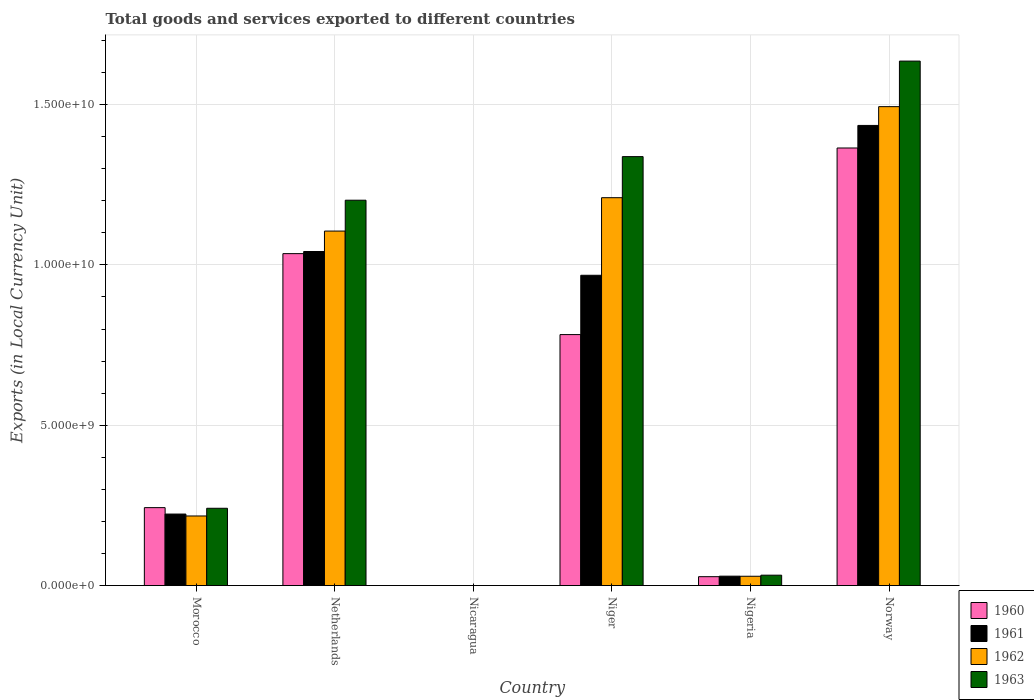How many different coloured bars are there?
Make the answer very short. 4. How many groups of bars are there?
Provide a succinct answer. 6. Are the number of bars per tick equal to the number of legend labels?
Ensure brevity in your answer.  Yes. Are the number of bars on each tick of the X-axis equal?
Your response must be concise. Yes. How many bars are there on the 5th tick from the left?
Provide a short and direct response. 4. In how many cases, is the number of bars for a given country not equal to the number of legend labels?
Provide a short and direct response. 0. What is the Amount of goods and services exports in 1961 in Netherlands?
Provide a succinct answer. 1.04e+1. Across all countries, what is the maximum Amount of goods and services exports in 1963?
Provide a succinct answer. 1.64e+1. Across all countries, what is the minimum Amount of goods and services exports in 1962?
Your answer should be very brief. 0.15. In which country was the Amount of goods and services exports in 1960 minimum?
Your response must be concise. Nicaragua. What is the total Amount of goods and services exports in 1960 in the graph?
Give a very brief answer. 3.45e+1. What is the difference between the Amount of goods and services exports in 1962 in Niger and that in Norway?
Ensure brevity in your answer.  -2.84e+09. What is the difference between the Amount of goods and services exports in 1963 in Norway and the Amount of goods and services exports in 1960 in Nicaragua?
Your answer should be compact. 1.64e+1. What is the average Amount of goods and services exports in 1961 per country?
Offer a terse response. 6.16e+09. What is the difference between the Amount of goods and services exports of/in 1961 and Amount of goods and services exports of/in 1960 in Morocco?
Your response must be concise. -2.00e+08. What is the ratio of the Amount of goods and services exports in 1960 in Nicaragua to that in Niger?
Offer a very short reply. 1.420758352495891e-11. Is the Amount of goods and services exports in 1960 in Morocco less than that in Netherlands?
Offer a terse response. Yes. What is the difference between the highest and the second highest Amount of goods and services exports in 1962?
Ensure brevity in your answer.  3.88e+09. What is the difference between the highest and the lowest Amount of goods and services exports in 1962?
Provide a succinct answer. 1.49e+1. In how many countries, is the Amount of goods and services exports in 1961 greater than the average Amount of goods and services exports in 1961 taken over all countries?
Your response must be concise. 3. Is the sum of the Amount of goods and services exports in 1961 in Niger and Nigeria greater than the maximum Amount of goods and services exports in 1963 across all countries?
Your answer should be very brief. No. What does the 1st bar from the left in Norway represents?
Provide a short and direct response. 1960. What does the 4th bar from the right in Nicaragua represents?
Provide a succinct answer. 1960. What is the difference between two consecutive major ticks on the Y-axis?
Give a very brief answer. 5.00e+09. How are the legend labels stacked?
Make the answer very short. Vertical. What is the title of the graph?
Offer a terse response. Total goods and services exported to different countries. What is the label or title of the X-axis?
Offer a terse response. Country. What is the label or title of the Y-axis?
Provide a succinct answer. Exports (in Local Currency Unit). What is the Exports (in Local Currency Unit) of 1960 in Morocco?
Make the answer very short. 2.43e+09. What is the Exports (in Local Currency Unit) of 1961 in Morocco?
Make the answer very short. 2.23e+09. What is the Exports (in Local Currency Unit) of 1962 in Morocco?
Provide a short and direct response. 2.17e+09. What is the Exports (in Local Currency Unit) in 1963 in Morocco?
Give a very brief answer. 2.41e+09. What is the Exports (in Local Currency Unit) in 1960 in Netherlands?
Give a very brief answer. 1.04e+1. What is the Exports (in Local Currency Unit) of 1961 in Netherlands?
Your response must be concise. 1.04e+1. What is the Exports (in Local Currency Unit) of 1962 in Netherlands?
Provide a short and direct response. 1.11e+1. What is the Exports (in Local Currency Unit) of 1963 in Netherlands?
Provide a short and direct response. 1.20e+1. What is the Exports (in Local Currency Unit) of 1960 in Nicaragua?
Make the answer very short. 0.11. What is the Exports (in Local Currency Unit) in 1961 in Nicaragua?
Provide a short and direct response. 0.12. What is the Exports (in Local Currency Unit) of 1962 in Nicaragua?
Your answer should be compact. 0.15. What is the Exports (in Local Currency Unit) of 1963 in Nicaragua?
Your answer should be very brief. 0.18. What is the Exports (in Local Currency Unit) in 1960 in Niger?
Your answer should be very brief. 7.83e+09. What is the Exports (in Local Currency Unit) in 1961 in Niger?
Keep it short and to the point. 9.68e+09. What is the Exports (in Local Currency Unit) of 1962 in Niger?
Offer a terse response. 1.21e+1. What is the Exports (in Local Currency Unit) of 1963 in Niger?
Offer a terse response. 1.34e+1. What is the Exports (in Local Currency Unit) in 1960 in Nigeria?
Ensure brevity in your answer.  2.77e+08. What is the Exports (in Local Currency Unit) in 1961 in Nigeria?
Offer a very short reply. 2.93e+08. What is the Exports (in Local Currency Unit) of 1962 in Nigeria?
Keep it short and to the point. 2.90e+08. What is the Exports (in Local Currency Unit) in 1963 in Nigeria?
Your answer should be very brief. 3.24e+08. What is the Exports (in Local Currency Unit) of 1960 in Norway?
Provide a succinct answer. 1.36e+1. What is the Exports (in Local Currency Unit) in 1961 in Norway?
Provide a short and direct response. 1.43e+1. What is the Exports (in Local Currency Unit) in 1962 in Norway?
Your response must be concise. 1.49e+1. What is the Exports (in Local Currency Unit) in 1963 in Norway?
Keep it short and to the point. 1.64e+1. Across all countries, what is the maximum Exports (in Local Currency Unit) in 1960?
Keep it short and to the point. 1.36e+1. Across all countries, what is the maximum Exports (in Local Currency Unit) in 1961?
Ensure brevity in your answer.  1.43e+1. Across all countries, what is the maximum Exports (in Local Currency Unit) in 1962?
Ensure brevity in your answer.  1.49e+1. Across all countries, what is the maximum Exports (in Local Currency Unit) of 1963?
Offer a very short reply. 1.64e+1. Across all countries, what is the minimum Exports (in Local Currency Unit) in 1960?
Provide a short and direct response. 0.11. Across all countries, what is the minimum Exports (in Local Currency Unit) in 1961?
Ensure brevity in your answer.  0.12. Across all countries, what is the minimum Exports (in Local Currency Unit) in 1962?
Your answer should be very brief. 0.15. Across all countries, what is the minimum Exports (in Local Currency Unit) in 1963?
Make the answer very short. 0.18. What is the total Exports (in Local Currency Unit) in 1960 in the graph?
Your answer should be compact. 3.45e+1. What is the total Exports (in Local Currency Unit) in 1961 in the graph?
Give a very brief answer. 3.70e+1. What is the total Exports (in Local Currency Unit) of 1962 in the graph?
Provide a succinct answer. 4.05e+1. What is the total Exports (in Local Currency Unit) of 1963 in the graph?
Give a very brief answer. 4.45e+1. What is the difference between the Exports (in Local Currency Unit) in 1960 in Morocco and that in Netherlands?
Your answer should be compact. -7.92e+09. What is the difference between the Exports (in Local Currency Unit) in 1961 in Morocco and that in Netherlands?
Offer a terse response. -8.19e+09. What is the difference between the Exports (in Local Currency Unit) in 1962 in Morocco and that in Netherlands?
Offer a very short reply. -8.88e+09. What is the difference between the Exports (in Local Currency Unit) in 1963 in Morocco and that in Netherlands?
Your response must be concise. -9.61e+09. What is the difference between the Exports (in Local Currency Unit) in 1960 in Morocco and that in Nicaragua?
Your answer should be very brief. 2.43e+09. What is the difference between the Exports (in Local Currency Unit) of 1961 in Morocco and that in Nicaragua?
Provide a short and direct response. 2.23e+09. What is the difference between the Exports (in Local Currency Unit) of 1962 in Morocco and that in Nicaragua?
Your response must be concise. 2.17e+09. What is the difference between the Exports (in Local Currency Unit) of 1963 in Morocco and that in Nicaragua?
Your answer should be very brief. 2.41e+09. What is the difference between the Exports (in Local Currency Unit) in 1960 in Morocco and that in Niger?
Your answer should be compact. -5.40e+09. What is the difference between the Exports (in Local Currency Unit) of 1961 in Morocco and that in Niger?
Give a very brief answer. -7.45e+09. What is the difference between the Exports (in Local Currency Unit) in 1962 in Morocco and that in Niger?
Your answer should be very brief. -9.92e+09. What is the difference between the Exports (in Local Currency Unit) of 1963 in Morocco and that in Niger?
Ensure brevity in your answer.  -1.10e+1. What is the difference between the Exports (in Local Currency Unit) in 1960 in Morocco and that in Nigeria?
Your answer should be very brief. 2.15e+09. What is the difference between the Exports (in Local Currency Unit) in 1961 in Morocco and that in Nigeria?
Your answer should be very brief. 1.94e+09. What is the difference between the Exports (in Local Currency Unit) in 1962 in Morocco and that in Nigeria?
Offer a very short reply. 1.88e+09. What is the difference between the Exports (in Local Currency Unit) in 1963 in Morocco and that in Nigeria?
Provide a succinct answer. 2.09e+09. What is the difference between the Exports (in Local Currency Unit) in 1960 in Morocco and that in Norway?
Your response must be concise. -1.12e+1. What is the difference between the Exports (in Local Currency Unit) in 1961 in Morocco and that in Norway?
Offer a terse response. -1.21e+1. What is the difference between the Exports (in Local Currency Unit) of 1962 in Morocco and that in Norway?
Your answer should be compact. -1.28e+1. What is the difference between the Exports (in Local Currency Unit) in 1963 in Morocco and that in Norway?
Ensure brevity in your answer.  -1.39e+1. What is the difference between the Exports (in Local Currency Unit) in 1960 in Netherlands and that in Nicaragua?
Your answer should be very brief. 1.04e+1. What is the difference between the Exports (in Local Currency Unit) of 1961 in Netherlands and that in Nicaragua?
Offer a very short reply. 1.04e+1. What is the difference between the Exports (in Local Currency Unit) in 1962 in Netherlands and that in Nicaragua?
Offer a very short reply. 1.11e+1. What is the difference between the Exports (in Local Currency Unit) of 1963 in Netherlands and that in Nicaragua?
Ensure brevity in your answer.  1.20e+1. What is the difference between the Exports (in Local Currency Unit) of 1960 in Netherlands and that in Niger?
Your answer should be very brief. 2.52e+09. What is the difference between the Exports (in Local Currency Unit) of 1961 in Netherlands and that in Niger?
Your answer should be very brief. 7.41e+08. What is the difference between the Exports (in Local Currency Unit) in 1962 in Netherlands and that in Niger?
Ensure brevity in your answer.  -1.04e+09. What is the difference between the Exports (in Local Currency Unit) of 1963 in Netherlands and that in Niger?
Offer a terse response. -1.36e+09. What is the difference between the Exports (in Local Currency Unit) of 1960 in Netherlands and that in Nigeria?
Offer a terse response. 1.01e+1. What is the difference between the Exports (in Local Currency Unit) of 1961 in Netherlands and that in Nigeria?
Your answer should be compact. 1.01e+1. What is the difference between the Exports (in Local Currency Unit) of 1962 in Netherlands and that in Nigeria?
Provide a short and direct response. 1.08e+1. What is the difference between the Exports (in Local Currency Unit) of 1963 in Netherlands and that in Nigeria?
Provide a succinct answer. 1.17e+1. What is the difference between the Exports (in Local Currency Unit) of 1960 in Netherlands and that in Norway?
Offer a very short reply. -3.29e+09. What is the difference between the Exports (in Local Currency Unit) in 1961 in Netherlands and that in Norway?
Ensure brevity in your answer.  -3.93e+09. What is the difference between the Exports (in Local Currency Unit) in 1962 in Netherlands and that in Norway?
Your answer should be compact. -3.88e+09. What is the difference between the Exports (in Local Currency Unit) in 1963 in Netherlands and that in Norway?
Make the answer very short. -4.34e+09. What is the difference between the Exports (in Local Currency Unit) in 1960 in Nicaragua and that in Niger?
Keep it short and to the point. -7.83e+09. What is the difference between the Exports (in Local Currency Unit) in 1961 in Nicaragua and that in Niger?
Give a very brief answer. -9.68e+09. What is the difference between the Exports (in Local Currency Unit) of 1962 in Nicaragua and that in Niger?
Offer a terse response. -1.21e+1. What is the difference between the Exports (in Local Currency Unit) of 1963 in Nicaragua and that in Niger?
Your answer should be compact. -1.34e+1. What is the difference between the Exports (in Local Currency Unit) of 1960 in Nicaragua and that in Nigeria?
Give a very brief answer. -2.77e+08. What is the difference between the Exports (in Local Currency Unit) in 1961 in Nicaragua and that in Nigeria?
Ensure brevity in your answer.  -2.93e+08. What is the difference between the Exports (in Local Currency Unit) of 1962 in Nicaragua and that in Nigeria?
Your answer should be compact. -2.90e+08. What is the difference between the Exports (in Local Currency Unit) of 1963 in Nicaragua and that in Nigeria?
Give a very brief answer. -3.24e+08. What is the difference between the Exports (in Local Currency Unit) in 1960 in Nicaragua and that in Norway?
Your answer should be very brief. -1.36e+1. What is the difference between the Exports (in Local Currency Unit) of 1961 in Nicaragua and that in Norway?
Your answer should be compact. -1.43e+1. What is the difference between the Exports (in Local Currency Unit) of 1962 in Nicaragua and that in Norway?
Provide a short and direct response. -1.49e+1. What is the difference between the Exports (in Local Currency Unit) of 1963 in Nicaragua and that in Norway?
Provide a short and direct response. -1.64e+1. What is the difference between the Exports (in Local Currency Unit) in 1960 in Niger and that in Nigeria?
Your answer should be very brief. 7.55e+09. What is the difference between the Exports (in Local Currency Unit) of 1961 in Niger and that in Nigeria?
Offer a very short reply. 9.38e+09. What is the difference between the Exports (in Local Currency Unit) in 1962 in Niger and that in Nigeria?
Offer a very short reply. 1.18e+1. What is the difference between the Exports (in Local Currency Unit) in 1963 in Niger and that in Nigeria?
Provide a succinct answer. 1.31e+1. What is the difference between the Exports (in Local Currency Unit) in 1960 in Niger and that in Norway?
Make the answer very short. -5.82e+09. What is the difference between the Exports (in Local Currency Unit) in 1961 in Niger and that in Norway?
Your answer should be compact. -4.67e+09. What is the difference between the Exports (in Local Currency Unit) in 1962 in Niger and that in Norway?
Your answer should be compact. -2.84e+09. What is the difference between the Exports (in Local Currency Unit) of 1963 in Niger and that in Norway?
Provide a short and direct response. -2.98e+09. What is the difference between the Exports (in Local Currency Unit) of 1960 in Nigeria and that in Norway?
Give a very brief answer. -1.34e+1. What is the difference between the Exports (in Local Currency Unit) of 1961 in Nigeria and that in Norway?
Provide a short and direct response. -1.41e+1. What is the difference between the Exports (in Local Currency Unit) in 1962 in Nigeria and that in Norway?
Give a very brief answer. -1.46e+1. What is the difference between the Exports (in Local Currency Unit) in 1963 in Nigeria and that in Norway?
Make the answer very short. -1.60e+1. What is the difference between the Exports (in Local Currency Unit) of 1960 in Morocco and the Exports (in Local Currency Unit) of 1961 in Netherlands?
Provide a succinct answer. -7.99e+09. What is the difference between the Exports (in Local Currency Unit) in 1960 in Morocco and the Exports (in Local Currency Unit) in 1962 in Netherlands?
Provide a succinct answer. -8.62e+09. What is the difference between the Exports (in Local Currency Unit) of 1960 in Morocco and the Exports (in Local Currency Unit) of 1963 in Netherlands?
Keep it short and to the point. -9.59e+09. What is the difference between the Exports (in Local Currency Unit) in 1961 in Morocco and the Exports (in Local Currency Unit) in 1962 in Netherlands?
Your response must be concise. -8.82e+09. What is the difference between the Exports (in Local Currency Unit) in 1961 in Morocco and the Exports (in Local Currency Unit) in 1963 in Netherlands?
Provide a succinct answer. -9.79e+09. What is the difference between the Exports (in Local Currency Unit) of 1962 in Morocco and the Exports (in Local Currency Unit) of 1963 in Netherlands?
Provide a succinct answer. -9.85e+09. What is the difference between the Exports (in Local Currency Unit) in 1960 in Morocco and the Exports (in Local Currency Unit) in 1961 in Nicaragua?
Provide a short and direct response. 2.43e+09. What is the difference between the Exports (in Local Currency Unit) of 1960 in Morocco and the Exports (in Local Currency Unit) of 1962 in Nicaragua?
Your response must be concise. 2.43e+09. What is the difference between the Exports (in Local Currency Unit) of 1960 in Morocco and the Exports (in Local Currency Unit) of 1963 in Nicaragua?
Ensure brevity in your answer.  2.43e+09. What is the difference between the Exports (in Local Currency Unit) in 1961 in Morocco and the Exports (in Local Currency Unit) in 1962 in Nicaragua?
Your response must be concise. 2.23e+09. What is the difference between the Exports (in Local Currency Unit) in 1961 in Morocco and the Exports (in Local Currency Unit) in 1963 in Nicaragua?
Ensure brevity in your answer.  2.23e+09. What is the difference between the Exports (in Local Currency Unit) in 1962 in Morocco and the Exports (in Local Currency Unit) in 1963 in Nicaragua?
Offer a terse response. 2.17e+09. What is the difference between the Exports (in Local Currency Unit) in 1960 in Morocco and the Exports (in Local Currency Unit) in 1961 in Niger?
Make the answer very short. -7.25e+09. What is the difference between the Exports (in Local Currency Unit) in 1960 in Morocco and the Exports (in Local Currency Unit) in 1962 in Niger?
Keep it short and to the point. -9.66e+09. What is the difference between the Exports (in Local Currency Unit) of 1960 in Morocco and the Exports (in Local Currency Unit) of 1963 in Niger?
Your answer should be very brief. -1.09e+1. What is the difference between the Exports (in Local Currency Unit) in 1961 in Morocco and the Exports (in Local Currency Unit) in 1962 in Niger?
Offer a very short reply. -9.86e+09. What is the difference between the Exports (in Local Currency Unit) in 1961 in Morocco and the Exports (in Local Currency Unit) in 1963 in Niger?
Provide a succinct answer. -1.11e+1. What is the difference between the Exports (in Local Currency Unit) of 1962 in Morocco and the Exports (in Local Currency Unit) of 1963 in Niger?
Your answer should be compact. -1.12e+1. What is the difference between the Exports (in Local Currency Unit) of 1960 in Morocco and the Exports (in Local Currency Unit) of 1961 in Nigeria?
Give a very brief answer. 2.14e+09. What is the difference between the Exports (in Local Currency Unit) in 1960 in Morocco and the Exports (in Local Currency Unit) in 1962 in Nigeria?
Offer a terse response. 2.14e+09. What is the difference between the Exports (in Local Currency Unit) in 1960 in Morocco and the Exports (in Local Currency Unit) in 1963 in Nigeria?
Offer a terse response. 2.11e+09. What is the difference between the Exports (in Local Currency Unit) of 1961 in Morocco and the Exports (in Local Currency Unit) of 1962 in Nigeria?
Give a very brief answer. 1.94e+09. What is the difference between the Exports (in Local Currency Unit) in 1961 in Morocco and the Exports (in Local Currency Unit) in 1963 in Nigeria?
Provide a succinct answer. 1.91e+09. What is the difference between the Exports (in Local Currency Unit) of 1962 in Morocco and the Exports (in Local Currency Unit) of 1963 in Nigeria?
Give a very brief answer. 1.85e+09. What is the difference between the Exports (in Local Currency Unit) in 1960 in Morocco and the Exports (in Local Currency Unit) in 1961 in Norway?
Offer a very short reply. -1.19e+1. What is the difference between the Exports (in Local Currency Unit) in 1960 in Morocco and the Exports (in Local Currency Unit) in 1962 in Norway?
Offer a very short reply. -1.25e+1. What is the difference between the Exports (in Local Currency Unit) of 1960 in Morocco and the Exports (in Local Currency Unit) of 1963 in Norway?
Your answer should be compact. -1.39e+1. What is the difference between the Exports (in Local Currency Unit) in 1961 in Morocco and the Exports (in Local Currency Unit) in 1962 in Norway?
Your answer should be compact. -1.27e+1. What is the difference between the Exports (in Local Currency Unit) in 1961 in Morocco and the Exports (in Local Currency Unit) in 1963 in Norway?
Your response must be concise. -1.41e+1. What is the difference between the Exports (in Local Currency Unit) in 1962 in Morocco and the Exports (in Local Currency Unit) in 1963 in Norway?
Give a very brief answer. -1.42e+1. What is the difference between the Exports (in Local Currency Unit) of 1960 in Netherlands and the Exports (in Local Currency Unit) of 1961 in Nicaragua?
Give a very brief answer. 1.04e+1. What is the difference between the Exports (in Local Currency Unit) of 1960 in Netherlands and the Exports (in Local Currency Unit) of 1962 in Nicaragua?
Provide a short and direct response. 1.04e+1. What is the difference between the Exports (in Local Currency Unit) of 1960 in Netherlands and the Exports (in Local Currency Unit) of 1963 in Nicaragua?
Make the answer very short. 1.04e+1. What is the difference between the Exports (in Local Currency Unit) in 1961 in Netherlands and the Exports (in Local Currency Unit) in 1962 in Nicaragua?
Give a very brief answer. 1.04e+1. What is the difference between the Exports (in Local Currency Unit) in 1961 in Netherlands and the Exports (in Local Currency Unit) in 1963 in Nicaragua?
Your answer should be compact. 1.04e+1. What is the difference between the Exports (in Local Currency Unit) in 1962 in Netherlands and the Exports (in Local Currency Unit) in 1963 in Nicaragua?
Give a very brief answer. 1.11e+1. What is the difference between the Exports (in Local Currency Unit) in 1960 in Netherlands and the Exports (in Local Currency Unit) in 1961 in Niger?
Offer a very short reply. 6.75e+08. What is the difference between the Exports (in Local Currency Unit) in 1960 in Netherlands and the Exports (in Local Currency Unit) in 1962 in Niger?
Keep it short and to the point. -1.74e+09. What is the difference between the Exports (in Local Currency Unit) of 1960 in Netherlands and the Exports (in Local Currency Unit) of 1963 in Niger?
Provide a short and direct response. -3.02e+09. What is the difference between the Exports (in Local Currency Unit) in 1961 in Netherlands and the Exports (in Local Currency Unit) in 1962 in Niger?
Give a very brief answer. -1.68e+09. What is the difference between the Exports (in Local Currency Unit) in 1961 in Netherlands and the Exports (in Local Currency Unit) in 1963 in Niger?
Offer a terse response. -2.96e+09. What is the difference between the Exports (in Local Currency Unit) in 1962 in Netherlands and the Exports (in Local Currency Unit) in 1963 in Niger?
Ensure brevity in your answer.  -2.32e+09. What is the difference between the Exports (in Local Currency Unit) of 1960 in Netherlands and the Exports (in Local Currency Unit) of 1961 in Nigeria?
Offer a terse response. 1.01e+1. What is the difference between the Exports (in Local Currency Unit) in 1960 in Netherlands and the Exports (in Local Currency Unit) in 1962 in Nigeria?
Keep it short and to the point. 1.01e+1. What is the difference between the Exports (in Local Currency Unit) in 1960 in Netherlands and the Exports (in Local Currency Unit) in 1963 in Nigeria?
Offer a very short reply. 1.00e+1. What is the difference between the Exports (in Local Currency Unit) in 1961 in Netherlands and the Exports (in Local Currency Unit) in 1962 in Nigeria?
Offer a very short reply. 1.01e+1. What is the difference between the Exports (in Local Currency Unit) of 1961 in Netherlands and the Exports (in Local Currency Unit) of 1963 in Nigeria?
Provide a succinct answer. 1.01e+1. What is the difference between the Exports (in Local Currency Unit) in 1962 in Netherlands and the Exports (in Local Currency Unit) in 1963 in Nigeria?
Provide a succinct answer. 1.07e+1. What is the difference between the Exports (in Local Currency Unit) in 1960 in Netherlands and the Exports (in Local Currency Unit) in 1961 in Norway?
Keep it short and to the point. -4.00e+09. What is the difference between the Exports (in Local Currency Unit) of 1960 in Netherlands and the Exports (in Local Currency Unit) of 1962 in Norway?
Your response must be concise. -4.58e+09. What is the difference between the Exports (in Local Currency Unit) in 1960 in Netherlands and the Exports (in Local Currency Unit) in 1963 in Norway?
Offer a very short reply. -6.00e+09. What is the difference between the Exports (in Local Currency Unit) of 1961 in Netherlands and the Exports (in Local Currency Unit) of 1962 in Norway?
Your answer should be very brief. -4.52e+09. What is the difference between the Exports (in Local Currency Unit) in 1961 in Netherlands and the Exports (in Local Currency Unit) in 1963 in Norway?
Give a very brief answer. -5.94e+09. What is the difference between the Exports (in Local Currency Unit) in 1962 in Netherlands and the Exports (in Local Currency Unit) in 1963 in Norway?
Keep it short and to the point. -5.30e+09. What is the difference between the Exports (in Local Currency Unit) of 1960 in Nicaragua and the Exports (in Local Currency Unit) of 1961 in Niger?
Keep it short and to the point. -9.68e+09. What is the difference between the Exports (in Local Currency Unit) of 1960 in Nicaragua and the Exports (in Local Currency Unit) of 1962 in Niger?
Ensure brevity in your answer.  -1.21e+1. What is the difference between the Exports (in Local Currency Unit) of 1960 in Nicaragua and the Exports (in Local Currency Unit) of 1963 in Niger?
Your answer should be very brief. -1.34e+1. What is the difference between the Exports (in Local Currency Unit) of 1961 in Nicaragua and the Exports (in Local Currency Unit) of 1962 in Niger?
Your response must be concise. -1.21e+1. What is the difference between the Exports (in Local Currency Unit) of 1961 in Nicaragua and the Exports (in Local Currency Unit) of 1963 in Niger?
Your response must be concise. -1.34e+1. What is the difference between the Exports (in Local Currency Unit) of 1962 in Nicaragua and the Exports (in Local Currency Unit) of 1963 in Niger?
Keep it short and to the point. -1.34e+1. What is the difference between the Exports (in Local Currency Unit) in 1960 in Nicaragua and the Exports (in Local Currency Unit) in 1961 in Nigeria?
Your answer should be compact. -2.93e+08. What is the difference between the Exports (in Local Currency Unit) in 1960 in Nicaragua and the Exports (in Local Currency Unit) in 1962 in Nigeria?
Your answer should be very brief. -2.90e+08. What is the difference between the Exports (in Local Currency Unit) in 1960 in Nicaragua and the Exports (in Local Currency Unit) in 1963 in Nigeria?
Offer a terse response. -3.24e+08. What is the difference between the Exports (in Local Currency Unit) in 1961 in Nicaragua and the Exports (in Local Currency Unit) in 1962 in Nigeria?
Give a very brief answer. -2.90e+08. What is the difference between the Exports (in Local Currency Unit) in 1961 in Nicaragua and the Exports (in Local Currency Unit) in 1963 in Nigeria?
Your answer should be very brief. -3.24e+08. What is the difference between the Exports (in Local Currency Unit) of 1962 in Nicaragua and the Exports (in Local Currency Unit) of 1963 in Nigeria?
Keep it short and to the point. -3.24e+08. What is the difference between the Exports (in Local Currency Unit) of 1960 in Nicaragua and the Exports (in Local Currency Unit) of 1961 in Norway?
Make the answer very short. -1.43e+1. What is the difference between the Exports (in Local Currency Unit) in 1960 in Nicaragua and the Exports (in Local Currency Unit) in 1962 in Norway?
Provide a short and direct response. -1.49e+1. What is the difference between the Exports (in Local Currency Unit) in 1960 in Nicaragua and the Exports (in Local Currency Unit) in 1963 in Norway?
Keep it short and to the point. -1.64e+1. What is the difference between the Exports (in Local Currency Unit) of 1961 in Nicaragua and the Exports (in Local Currency Unit) of 1962 in Norway?
Offer a terse response. -1.49e+1. What is the difference between the Exports (in Local Currency Unit) of 1961 in Nicaragua and the Exports (in Local Currency Unit) of 1963 in Norway?
Provide a short and direct response. -1.64e+1. What is the difference between the Exports (in Local Currency Unit) in 1962 in Nicaragua and the Exports (in Local Currency Unit) in 1963 in Norway?
Provide a succinct answer. -1.64e+1. What is the difference between the Exports (in Local Currency Unit) of 1960 in Niger and the Exports (in Local Currency Unit) of 1961 in Nigeria?
Your response must be concise. 7.53e+09. What is the difference between the Exports (in Local Currency Unit) in 1960 in Niger and the Exports (in Local Currency Unit) in 1962 in Nigeria?
Keep it short and to the point. 7.54e+09. What is the difference between the Exports (in Local Currency Unit) in 1960 in Niger and the Exports (in Local Currency Unit) in 1963 in Nigeria?
Offer a very short reply. 7.50e+09. What is the difference between the Exports (in Local Currency Unit) of 1961 in Niger and the Exports (in Local Currency Unit) of 1962 in Nigeria?
Offer a very short reply. 9.39e+09. What is the difference between the Exports (in Local Currency Unit) of 1961 in Niger and the Exports (in Local Currency Unit) of 1963 in Nigeria?
Offer a very short reply. 9.35e+09. What is the difference between the Exports (in Local Currency Unit) of 1962 in Niger and the Exports (in Local Currency Unit) of 1963 in Nigeria?
Make the answer very short. 1.18e+1. What is the difference between the Exports (in Local Currency Unit) of 1960 in Niger and the Exports (in Local Currency Unit) of 1961 in Norway?
Offer a terse response. -6.52e+09. What is the difference between the Exports (in Local Currency Unit) in 1960 in Niger and the Exports (in Local Currency Unit) in 1962 in Norway?
Your response must be concise. -7.11e+09. What is the difference between the Exports (in Local Currency Unit) in 1960 in Niger and the Exports (in Local Currency Unit) in 1963 in Norway?
Your answer should be compact. -8.53e+09. What is the difference between the Exports (in Local Currency Unit) in 1961 in Niger and the Exports (in Local Currency Unit) in 1962 in Norway?
Your response must be concise. -5.26e+09. What is the difference between the Exports (in Local Currency Unit) in 1961 in Niger and the Exports (in Local Currency Unit) in 1963 in Norway?
Your response must be concise. -6.68e+09. What is the difference between the Exports (in Local Currency Unit) of 1962 in Niger and the Exports (in Local Currency Unit) of 1963 in Norway?
Ensure brevity in your answer.  -4.26e+09. What is the difference between the Exports (in Local Currency Unit) of 1960 in Nigeria and the Exports (in Local Currency Unit) of 1961 in Norway?
Provide a succinct answer. -1.41e+1. What is the difference between the Exports (in Local Currency Unit) of 1960 in Nigeria and the Exports (in Local Currency Unit) of 1962 in Norway?
Keep it short and to the point. -1.47e+1. What is the difference between the Exports (in Local Currency Unit) in 1960 in Nigeria and the Exports (in Local Currency Unit) in 1963 in Norway?
Ensure brevity in your answer.  -1.61e+1. What is the difference between the Exports (in Local Currency Unit) in 1961 in Nigeria and the Exports (in Local Currency Unit) in 1962 in Norway?
Provide a succinct answer. -1.46e+1. What is the difference between the Exports (in Local Currency Unit) in 1961 in Nigeria and the Exports (in Local Currency Unit) in 1963 in Norway?
Ensure brevity in your answer.  -1.61e+1. What is the difference between the Exports (in Local Currency Unit) of 1962 in Nigeria and the Exports (in Local Currency Unit) of 1963 in Norway?
Offer a very short reply. -1.61e+1. What is the average Exports (in Local Currency Unit) of 1960 per country?
Give a very brief answer. 5.75e+09. What is the average Exports (in Local Currency Unit) in 1961 per country?
Provide a succinct answer. 6.16e+09. What is the average Exports (in Local Currency Unit) in 1962 per country?
Your response must be concise. 6.76e+09. What is the average Exports (in Local Currency Unit) in 1963 per country?
Provide a succinct answer. 7.41e+09. What is the difference between the Exports (in Local Currency Unit) in 1960 and Exports (in Local Currency Unit) in 1961 in Morocco?
Your response must be concise. 2.00e+08. What is the difference between the Exports (in Local Currency Unit) of 1960 and Exports (in Local Currency Unit) of 1962 in Morocco?
Make the answer very short. 2.60e+08. What is the difference between the Exports (in Local Currency Unit) in 1961 and Exports (in Local Currency Unit) in 1962 in Morocco?
Give a very brief answer. 6.00e+07. What is the difference between the Exports (in Local Currency Unit) in 1961 and Exports (in Local Currency Unit) in 1963 in Morocco?
Provide a short and direct response. -1.80e+08. What is the difference between the Exports (in Local Currency Unit) in 1962 and Exports (in Local Currency Unit) in 1963 in Morocco?
Offer a terse response. -2.40e+08. What is the difference between the Exports (in Local Currency Unit) in 1960 and Exports (in Local Currency Unit) in 1961 in Netherlands?
Give a very brief answer. -6.60e+07. What is the difference between the Exports (in Local Currency Unit) in 1960 and Exports (in Local Currency Unit) in 1962 in Netherlands?
Keep it short and to the point. -7.03e+08. What is the difference between the Exports (in Local Currency Unit) of 1960 and Exports (in Local Currency Unit) of 1963 in Netherlands?
Ensure brevity in your answer.  -1.67e+09. What is the difference between the Exports (in Local Currency Unit) of 1961 and Exports (in Local Currency Unit) of 1962 in Netherlands?
Your answer should be compact. -6.37e+08. What is the difference between the Exports (in Local Currency Unit) of 1961 and Exports (in Local Currency Unit) of 1963 in Netherlands?
Your answer should be very brief. -1.60e+09. What is the difference between the Exports (in Local Currency Unit) in 1962 and Exports (in Local Currency Unit) in 1963 in Netherlands?
Offer a terse response. -9.62e+08. What is the difference between the Exports (in Local Currency Unit) in 1960 and Exports (in Local Currency Unit) in 1961 in Nicaragua?
Make the answer very short. -0.01. What is the difference between the Exports (in Local Currency Unit) in 1960 and Exports (in Local Currency Unit) in 1962 in Nicaragua?
Offer a very short reply. -0.04. What is the difference between the Exports (in Local Currency Unit) of 1960 and Exports (in Local Currency Unit) of 1963 in Nicaragua?
Your response must be concise. -0.07. What is the difference between the Exports (in Local Currency Unit) of 1961 and Exports (in Local Currency Unit) of 1962 in Nicaragua?
Your response must be concise. -0.03. What is the difference between the Exports (in Local Currency Unit) in 1961 and Exports (in Local Currency Unit) in 1963 in Nicaragua?
Give a very brief answer. -0.06. What is the difference between the Exports (in Local Currency Unit) in 1962 and Exports (in Local Currency Unit) in 1963 in Nicaragua?
Your answer should be very brief. -0.03. What is the difference between the Exports (in Local Currency Unit) in 1960 and Exports (in Local Currency Unit) in 1961 in Niger?
Provide a short and direct response. -1.85e+09. What is the difference between the Exports (in Local Currency Unit) of 1960 and Exports (in Local Currency Unit) of 1962 in Niger?
Provide a succinct answer. -4.27e+09. What is the difference between the Exports (in Local Currency Unit) in 1960 and Exports (in Local Currency Unit) in 1963 in Niger?
Provide a succinct answer. -5.55e+09. What is the difference between the Exports (in Local Currency Unit) of 1961 and Exports (in Local Currency Unit) of 1962 in Niger?
Offer a terse response. -2.42e+09. What is the difference between the Exports (in Local Currency Unit) of 1961 and Exports (in Local Currency Unit) of 1963 in Niger?
Give a very brief answer. -3.70e+09. What is the difference between the Exports (in Local Currency Unit) in 1962 and Exports (in Local Currency Unit) in 1963 in Niger?
Your response must be concise. -1.28e+09. What is the difference between the Exports (in Local Currency Unit) in 1960 and Exports (in Local Currency Unit) in 1961 in Nigeria?
Provide a succinct answer. -1.61e+07. What is the difference between the Exports (in Local Currency Unit) of 1960 and Exports (in Local Currency Unit) of 1962 in Nigeria?
Ensure brevity in your answer.  -1.30e+07. What is the difference between the Exports (in Local Currency Unit) of 1960 and Exports (in Local Currency Unit) of 1963 in Nigeria?
Your answer should be compact. -4.69e+07. What is the difference between the Exports (in Local Currency Unit) of 1961 and Exports (in Local Currency Unit) of 1962 in Nigeria?
Your answer should be compact. 3.12e+06. What is the difference between the Exports (in Local Currency Unit) in 1961 and Exports (in Local Currency Unit) in 1963 in Nigeria?
Your response must be concise. -3.08e+07. What is the difference between the Exports (in Local Currency Unit) in 1962 and Exports (in Local Currency Unit) in 1963 in Nigeria?
Ensure brevity in your answer.  -3.40e+07. What is the difference between the Exports (in Local Currency Unit) of 1960 and Exports (in Local Currency Unit) of 1961 in Norway?
Give a very brief answer. -7.04e+08. What is the difference between the Exports (in Local Currency Unit) of 1960 and Exports (in Local Currency Unit) of 1962 in Norway?
Give a very brief answer. -1.29e+09. What is the difference between the Exports (in Local Currency Unit) of 1960 and Exports (in Local Currency Unit) of 1963 in Norway?
Ensure brevity in your answer.  -2.71e+09. What is the difference between the Exports (in Local Currency Unit) in 1961 and Exports (in Local Currency Unit) in 1962 in Norway?
Provide a succinct answer. -5.86e+08. What is the difference between the Exports (in Local Currency Unit) of 1961 and Exports (in Local Currency Unit) of 1963 in Norway?
Ensure brevity in your answer.  -2.01e+09. What is the difference between the Exports (in Local Currency Unit) of 1962 and Exports (in Local Currency Unit) of 1963 in Norway?
Offer a very short reply. -1.42e+09. What is the ratio of the Exports (in Local Currency Unit) in 1960 in Morocco to that in Netherlands?
Your answer should be compact. 0.23. What is the ratio of the Exports (in Local Currency Unit) in 1961 in Morocco to that in Netherlands?
Make the answer very short. 0.21. What is the ratio of the Exports (in Local Currency Unit) of 1962 in Morocco to that in Netherlands?
Your answer should be very brief. 0.2. What is the ratio of the Exports (in Local Currency Unit) of 1963 in Morocco to that in Netherlands?
Give a very brief answer. 0.2. What is the ratio of the Exports (in Local Currency Unit) of 1960 in Morocco to that in Nicaragua?
Your response must be concise. 2.19e+1. What is the ratio of the Exports (in Local Currency Unit) of 1961 in Morocco to that in Nicaragua?
Your answer should be very brief. 1.89e+1. What is the ratio of the Exports (in Local Currency Unit) in 1962 in Morocco to that in Nicaragua?
Offer a terse response. 1.47e+1. What is the ratio of the Exports (in Local Currency Unit) of 1963 in Morocco to that in Nicaragua?
Offer a very short reply. 1.36e+1. What is the ratio of the Exports (in Local Currency Unit) of 1960 in Morocco to that in Niger?
Make the answer very short. 0.31. What is the ratio of the Exports (in Local Currency Unit) of 1961 in Morocco to that in Niger?
Keep it short and to the point. 0.23. What is the ratio of the Exports (in Local Currency Unit) in 1962 in Morocco to that in Niger?
Offer a very short reply. 0.18. What is the ratio of the Exports (in Local Currency Unit) in 1963 in Morocco to that in Niger?
Offer a terse response. 0.18. What is the ratio of the Exports (in Local Currency Unit) in 1960 in Morocco to that in Nigeria?
Ensure brevity in your answer.  8.77. What is the ratio of the Exports (in Local Currency Unit) of 1961 in Morocco to that in Nigeria?
Provide a short and direct response. 7.61. What is the ratio of the Exports (in Local Currency Unit) in 1962 in Morocco to that in Nigeria?
Offer a very short reply. 7.48. What is the ratio of the Exports (in Local Currency Unit) of 1963 in Morocco to that in Nigeria?
Offer a terse response. 7.44. What is the ratio of the Exports (in Local Currency Unit) in 1960 in Morocco to that in Norway?
Your answer should be very brief. 0.18. What is the ratio of the Exports (in Local Currency Unit) of 1961 in Morocco to that in Norway?
Give a very brief answer. 0.16. What is the ratio of the Exports (in Local Currency Unit) in 1962 in Morocco to that in Norway?
Offer a very short reply. 0.15. What is the ratio of the Exports (in Local Currency Unit) in 1963 in Morocco to that in Norway?
Your response must be concise. 0.15. What is the ratio of the Exports (in Local Currency Unit) in 1960 in Netherlands to that in Nicaragua?
Your answer should be very brief. 9.31e+1. What is the ratio of the Exports (in Local Currency Unit) in 1961 in Netherlands to that in Nicaragua?
Provide a short and direct response. 8.81e+1. What is the ratio of the Exports (in Local Currency Unit) of 1962 in Netherlands to that in Nicaragua?
Ensure brevity in your answer.  7.51e+1. What is the ratio of the Exports (in Local Currency Unit) of 1963 in Netherlands to that in Nicaragua?
Your response must be concise. 6.78e+1. What is the ratio of the Exports (in Local Currency Unit) in 1960 in Netherlands to that in Niger?
Keep it short and to the point. 1.32. What is the ratio of the Exports (in Local Currency Unit) in 1961 in Netherlands to that in Niger?
Offer a very short reply. 1.08. What is the ratio of the Exports (in Local Currency Unit) of 1962 in Netherlands to that in Niger?
Ensure brevity in your answer.  0.91. What is the ratio of the Exports (in Local Currency Unit) of 1963 in Netherlands to that in Niger?
Offer a terse response. 0.9. What is the ratio of the Exports (in Local Currency Unit) of 1960 in Netherlands to that in Nigeria?
Provide a succinct answer. 37.37. What is the ratio of the Exports (in Local Currency Unit) of 1961 in Netherlands to that in Nigeria?
Give a very brief answer. 35.54. What is the ratio of the Exports (in Local Currency Unit) in 1962 in Netherlands to that in Nigeria?
Offer a terse response. 38.12. What is the ratio of the Exports (in Local Currency Unit) in 1963 in Netherlands to that in Nigeria?
Give a very brief answer. 37.1. What is the ratio of the Exports (in Local Currency Unit) in 1960 in Netherlands to that in Norway?
Your response must be concise. 0.76. What is the ratio of the Exports (in Local Currency Unit) of 1961 in Netherlands to that in Norway?
Offer a very short reply. 0.73. What is the ratio of the Exports (in Local Currency Unit) of 1962 in Netherlands to that in Norway?
Your answer should be very brief. 0.74. What is the ratio of the Exports (in Local Currency Unit) of 1963 in Netherlands to that in Norway?
Offer a terse response. 0.73. What is the ratio of the Exports (in Local Currency Unit) of 1963 in Nicaragua to that in Niger?
Provide a succinct answer. 0. What is the ratio of the Exports (in Local Currency Unit) of 1962 in Nicaragua to that in Nigeria?
Ensure brevity in your answer.  0. What is the ratio of the Exports (in Local Currency Unit) of 1960 in Niger to that in Nigeria?
Make the answer very short. 28.25. What is the ratio of the Exports (in Local Currency Unit) of 1961 in Niger to that in Nigeria?
Give a very brief answer. 33.01. What is the ratio of the Exports (in Local Currency Unit) of 1962 in Niger to that in Nigeria?
Make the answer very short. 41.71. What is the ratio of the Exports (in Local Currency Unit) of 1963 in Niger to that in Nigeria?
Provide a succinct answer. 41.29. What is the ratio of the Exports (in Local Currency Unit) of 1960 in Niger to that in Norway?
Provide a succinct answer. 0.57. What is the ratio of the Exports (in Local Currency Unit) in 1961 in Niger to that in Norway?
Your answer should be very brief. 0.67. What is the ratio of the Exports (in Local Currency Unit) in 1962 in Niger to that in Norway?
Provide a short and direct response. 0.81. What is the ratio of the Exports (in Local Currency Unit) in 1963 in Niger to that in Norway?
Keep it short and to the point. 0.82. What is the ratio of the Exports (in Local Currency Unit) in 1960 in Nigeria to that in Norway?
Offer a terse response. 0.02. What is the ratio of the Exports (in Local Currency Unit) in 1961 in Nigeria to that in Norway?
Give a very brief answer. 0.02. What is the ratio of the Exports (in Local Currency Unit) in 1962 in Nigeria to that in Norway?
Offer a terse response. 0.02. What is the ratio of the Exports (in Local Currency Unit) in 1963 in Nigeria to that in Norway?
Give a very brief answer. 0.02. What is the difference between the highest and the second highest Exports (in Local Currency Unit) of 1960?
Keep it short and to the point. 3.29e+09. What is the difference between the highest and the second highest Exports (in Local Currency Unit) in 1961?
Give a very brief answer. 3.93e+09. What is the difference between the highest and the second highest Exports (in Local Currency Unit) of 1962?
Your answer should be compact. 2.84e+09. What is the difference between the highest and the second highest Exports (in Local Currency Unit) in 1963?
Your answer should be very brief. 2.98e+09. What is the difference between the highest and the lowest Exports (in Local Currency Unit) in 1960?
Provide a short and direct response. 1.36e+1. What is the difference between the highest and the lowest Exports (in Local Currency Unit) of 1961?
Ensure brevity in your answer.  1.43e+1. What is the difference between the highest and the lowest Exports (in Local Currency Unit) of 1962?
Keep it short and to the point. 1.49e+1. What is the difference between the highest and the lowest Exports (in Local Currency Unit) in 1963?
Provide a short and direct response. 1.64e+1. 